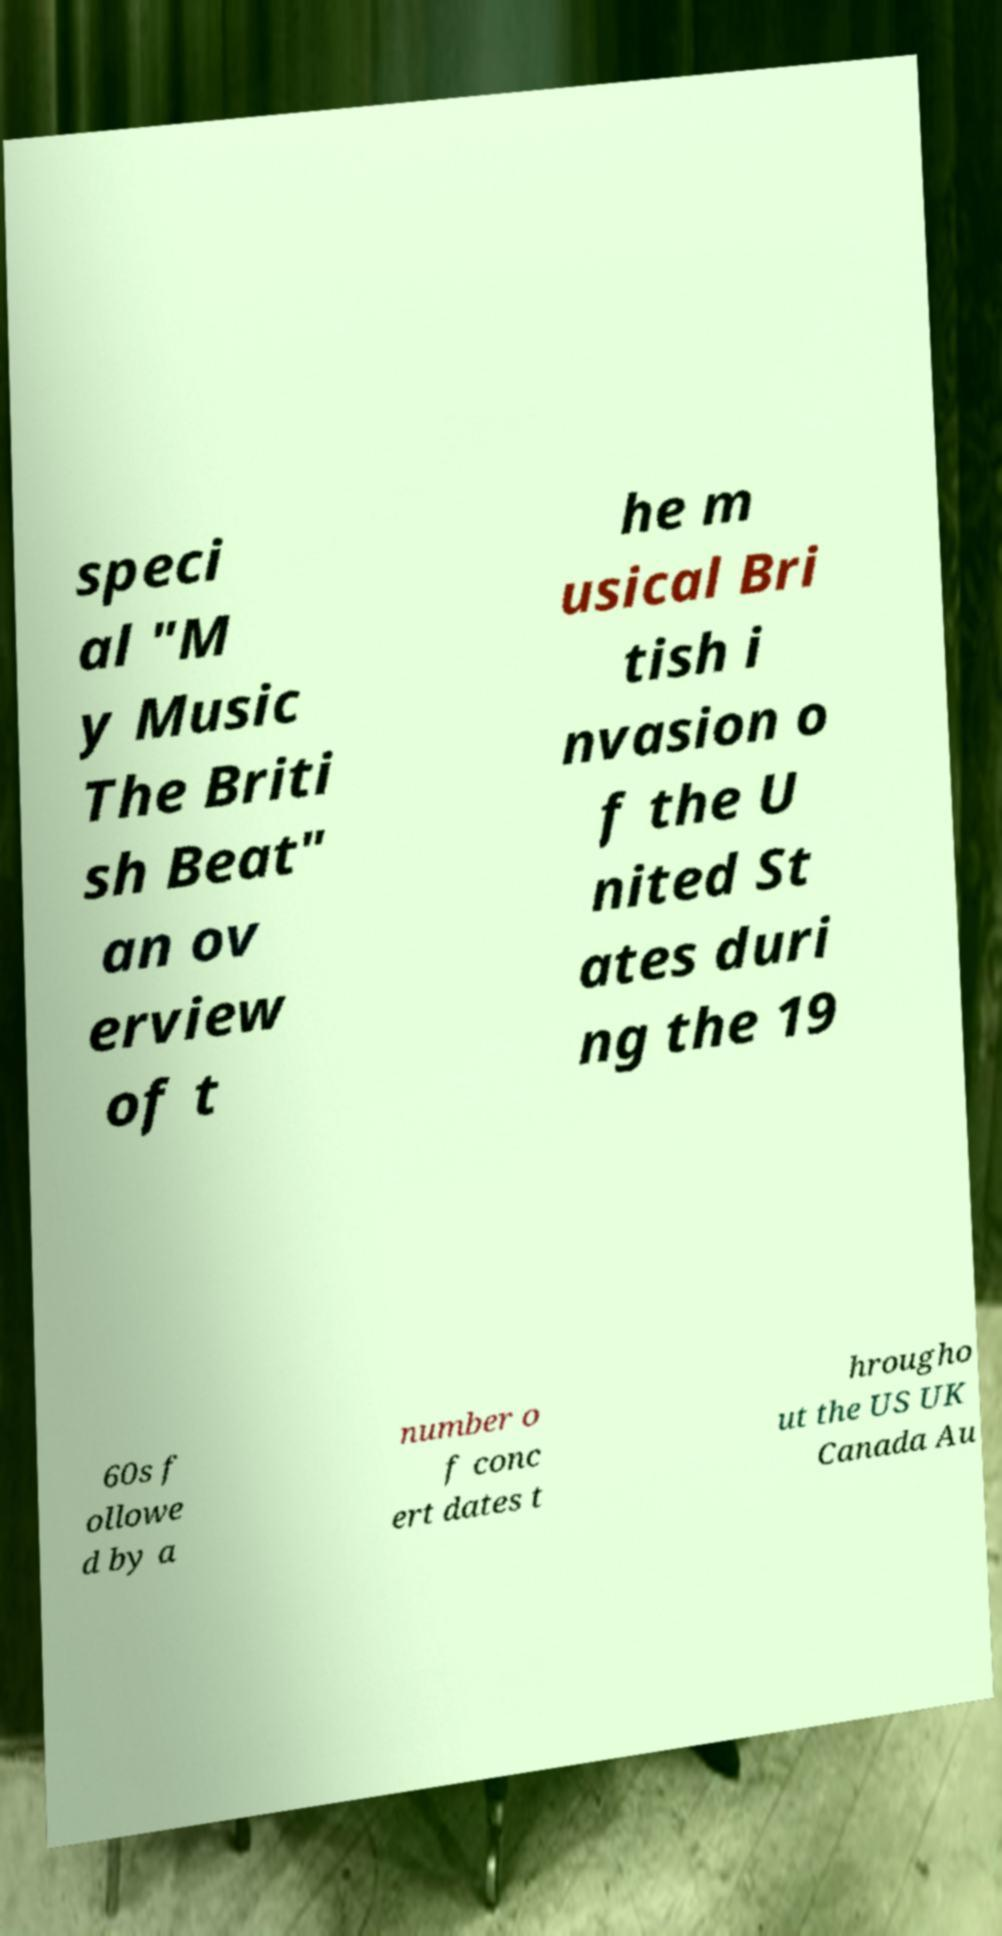Could you extract and type out the text from this image? speci al "M y Music The Briti sh Beat" an ov erview of t he m usical Bri tish i nvasion o f the U nited St ates duri ng the 19 60s f ollowe d by a number o f conc ert dates t hrougho ut the US UK Canada Au 